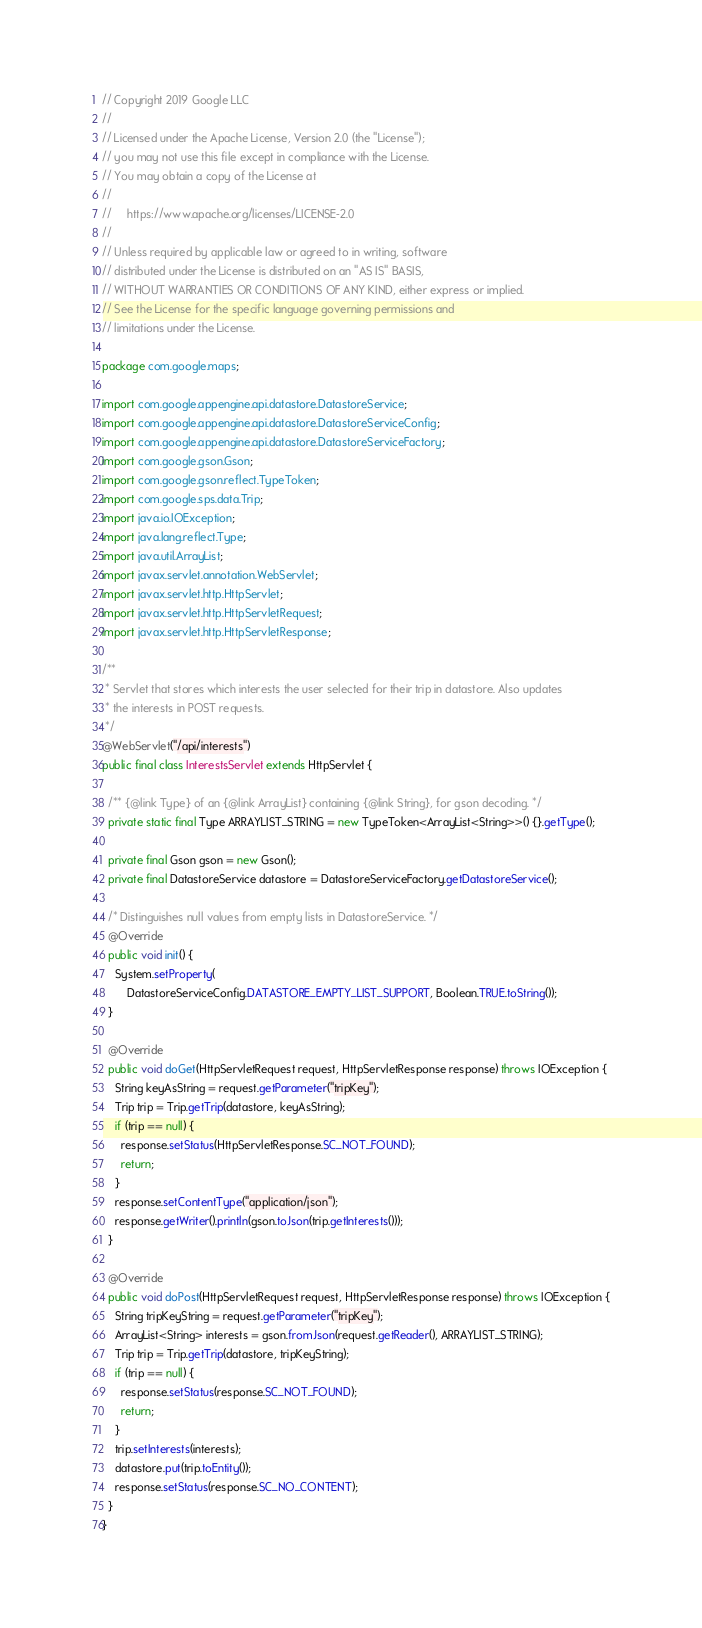<code> <loc_0><loc_0><loc_500><loc_500><_Java_>// Copyright 2019 Google LLC
//
// Licensed under the Apache License, Version 2.0 (the "License");
// you may not use this file except in compliance with the License.
// You may obtain a copy of the License at
//
//     https://www.apache.org/licenses/LICENSE-2.0
//
// Unless required by applicable law or agreed to in writing, software
// distributed under the License is distributed on an "AS IS" BASIS,
// WITHOUT WARRANTIES OR CONDITIONS OF ANY KIND, either express or implied.
// See the License for the specific language governing permissions and
// limitations under the License.

package com.google.maps;

import com.google.appengine.api.datastore.DatastoreService;
import com.google.appengine.api.datastore.DatastoreServiceConfig;
import com.google.appengine.api.datastore.DatastoreServiceFactory;
import com.google.gson.Gson;
import com.google.gson.reflect.TypeToken;
import com.google.sps.data.Trip;
import java.io.IOException;
import java.lang.reflect.Type;
import java.util.ArrayList;
import javax.servlet.annotation.WebServlet;
import javax.servlet.http.HttpServlet;
import javax.servlet.http.HttpServletRequest;
import javax.servlet.http.HttpServletResponse;

/**
 * Servlet that stores which interests the user selected for their trip in datastore. Also updates
 * the interests in POST requests.
 */
@WebServlet("/api/interests")
public final class InterestsServlet extends HttpServlet {

  /** {@link Type} of an {@link ArrayList} containing {@link String}, for gson decoding. */
  private static final Type ARRAYLIST_STRING = new TypeToken<ArrayList<String>>() {}.getType();

  private final Gson gson = new Gson();
  private final DatastoreService datastore = DatastoreServiceFactory.getDatastoreService();

  /* Distinguishes null values from empty lists in DatastoreService. */
  @Override
  public void init() {
    System.setProperty(
        DatastoreServiceConfig.DATASTORE_EMPTY_LIST_SUPPORT, Boolean.TRUE.toString());
  }

  @Override
  public void doGet(HttpServletRequest request, HttpServletResponse response) throws IOException {
    String keyAsString = request.getParameter("tripKey");
    Trip trip = Trip.getTrip(datastore, keyAsString);
    if (trip == null) {
      response.setStatus(HttpServletResponse.SC_NOT_FOUND);
      return;
    }
    response.setContentType("application/json");
    response.getWriter().println(gson.toJson(trip.getInterests()));
  }

  @Override
  public void doPost(HttpServletRequest request, HttpServletResponse response) throws IOException {
    String tripKeyString = request.getParameter("tripKey");
    ArrayList<String> interests = gson.fromJson(request.getReader(), ARRAYLIST_STRING);
    Trip trip = Trip.getTrip(datastore, tripKeyString);
    if (trip == null) {
      response.setStatus(response.SC_NOT_FOUND);
      return;
    }
    trip.setInterests(interests);
    datastore.put(trip.toEntity());
    response.setStatus(response.SC_NO_CONTENT);
  }
}
</code> 